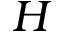<formula> <loc_0><loc_0><loc_500><loc_500>H</formula> 